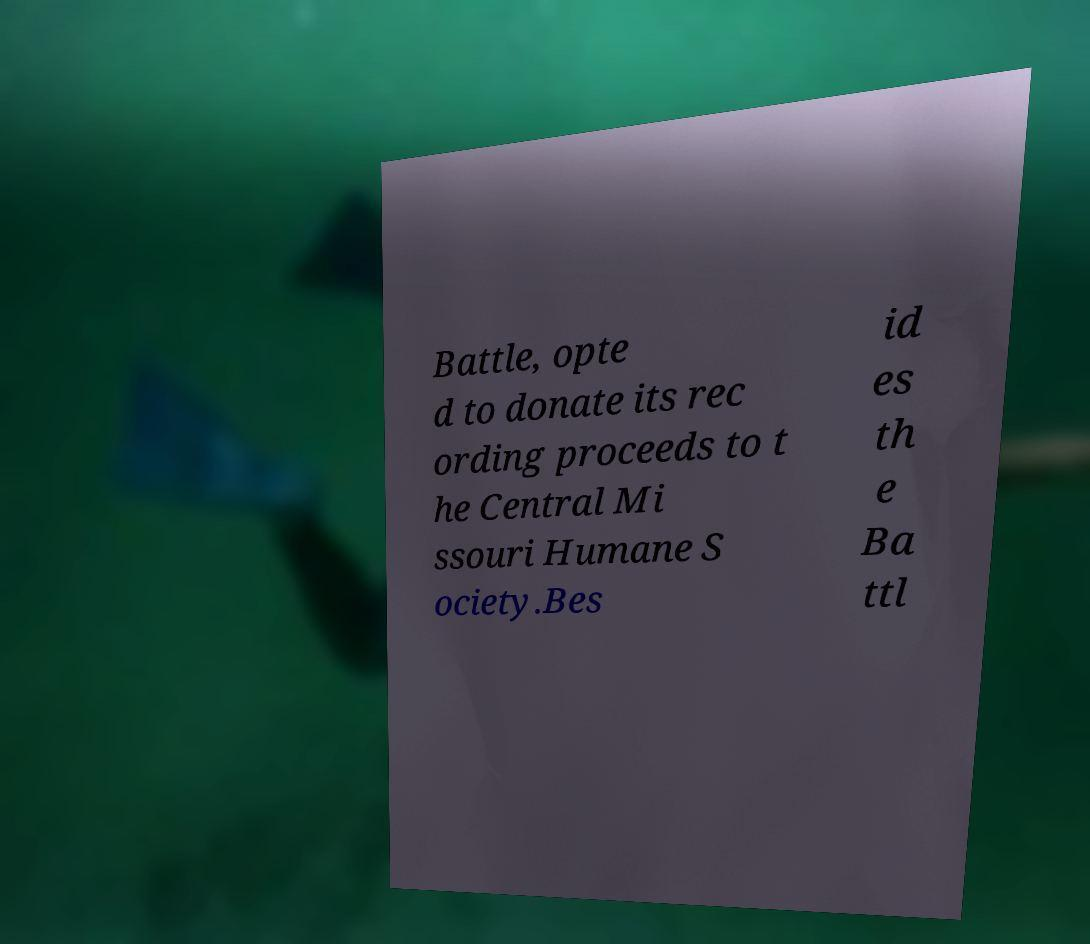What messages or text are displayed in this image? I need them in a readable, typed format. Battle, opte d to donate its rec ording proceeds to t he Central Mi ssouri Humane S ociety.Bes id es th e Ba ttl 